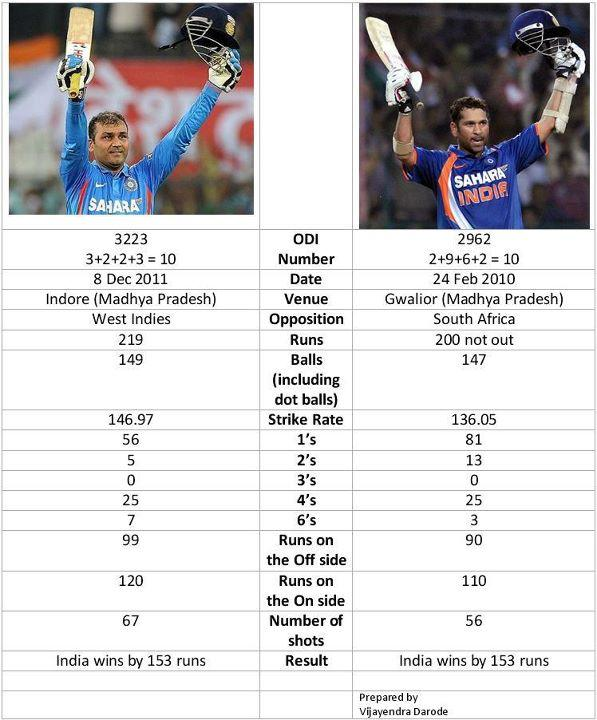Highlight a few significant elements in this photo. On day 3223, the cricket match took place in Indore (Madhya Pradesh). The ODI 3223 match was held on December 8, 2011. On February 24, 2010, a One Day International (ODI) match was played. The match number of this ODI is 2962. In the match where 7 sixes were scored, the total number of runs was 3223. ODI 2962 was played at Gwalior (Madhya Pradesh). 